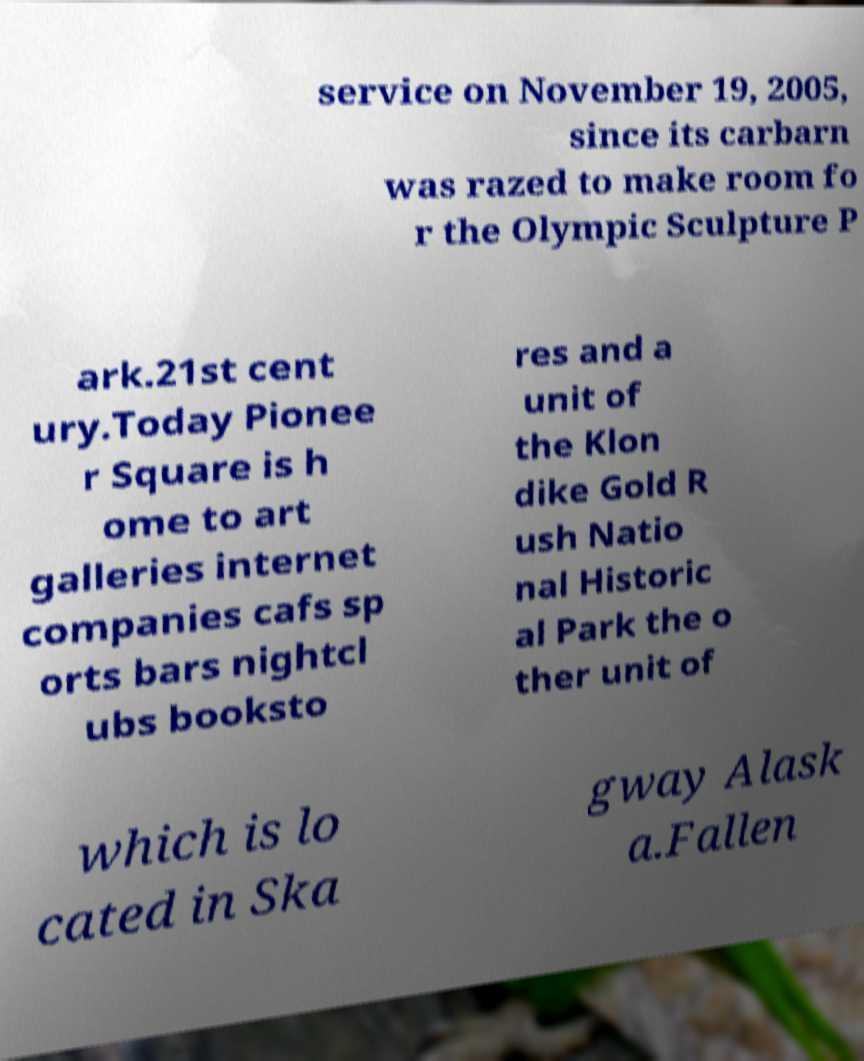Could you extract and type out the text from this image? service on November 19, 2005, since its carbarn was razed to make room fo r the Olympic Sculpture P ark.21st cent ury.Today Pionee r Square is h ome to art galleries internet companies cafs sp orts bars nightcl ubs booksto res and a unit of the Klon dike Gold R ush Natio nal Historic al Park the o ther unit of which is lo cated in Ska gway Alask a.Fallen 